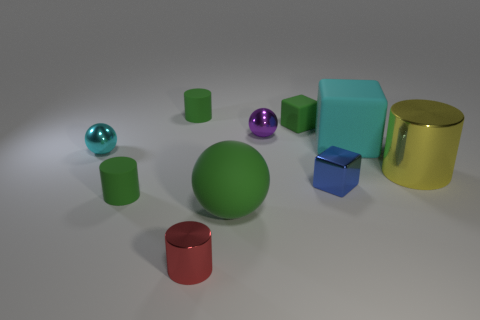Is the size of the purple object the same as the sphere in front of the big yellow cylinder?
Ensure brevity in your answer.  No. There is a object that is the same color as the large rubber cube; what is its material?
Your answer should be compact. Metal. There is a block that is behind the small purple sphere; is its size the same as the metallic cylinder behind the tiny blue shiny thing?
Your answer should be compact. No. Does the matte cylinder that is behind the cyan cube have the same size as the large shiny object?
Ensure brevity in your answer.  No. How big is the red metallic cylinder?
Keep it short and to the point. Small. There is a big ball; is its color the same as the small cube that is behind the blue metal thing?
Provide a short and direct response. Yes. What color is the matte cylinder on the left side of the cylinder behind the small purple shiny sphere?
Your response must be concise. Green. Is the shape of the tiny green thing in front of the big metallic cylinder the same as  the tiny red metal thing?
Give a very brief answer. Yes. How many tiny things are both behind the large sphere and in front of the shiny block?
Your response must be concise. 1. There is a small rubber object right of the cylinder in front of the small green matte thing that is in front of the large yellow metal cylinder; what color is it?
Offer a terse response. Green. 